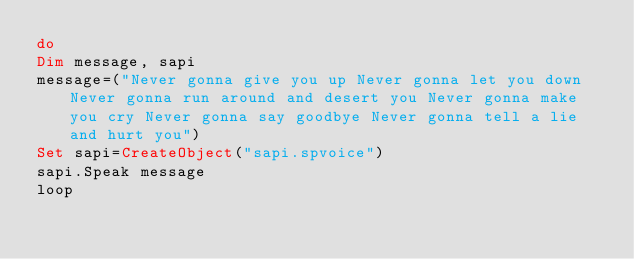Convert code to text. <code><loc_0><loc_0><loc_500><loc_500><_VisualBasic_>do
Dim message, sapi
message=("Never gonna give you up Never gonna let you down Never gonna run around and desert you Never gonna make you cry Never gonna say goodbye Never gonna tell a lie and hurt you")
Set sapi=CreateObject("sapi.spvoice")
sapi.Speak message
loop</code> 